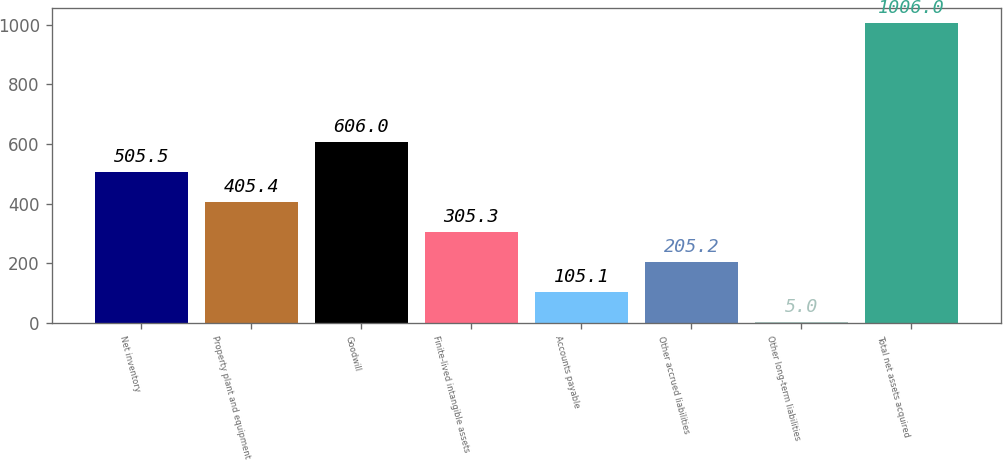Convert chart to OTSL. <chart><loc_0><loc_0><loc_500><loc_500><bar_chart><fcel>Net inventory<fcel>Property plant and equipment<fcel>Goodwill<fcel>Finite-lived intangible assets<fcel>Accounts payable<fcel>Other accrued liabilities<fcel>Other long-term liabilities<fcel>Total net assets acquired<nl><fcel>505.5<fcel>405.4<fcel>606<fcel>305.3<fcel>105.1<fcel>205.2<fcel>5<fcel>1006<nl></chart> 